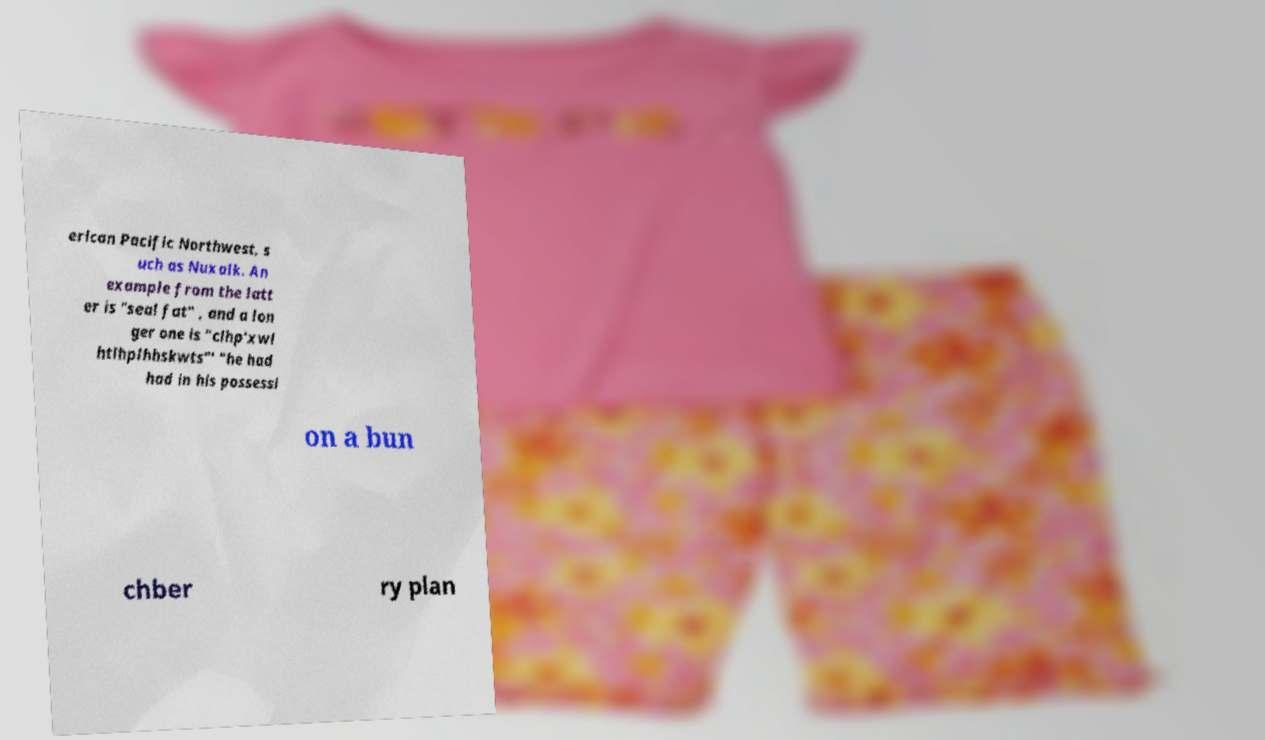Please read and relay the text visible in this image. What does it say? erican Pacific Northwest, s uch as Nuxalk. An example from the latt er is "seal fat" , and a lon ger one is "clhp'xwl htlhplhhskwts"' "he had had in his possessi on a bun chber ry plan 